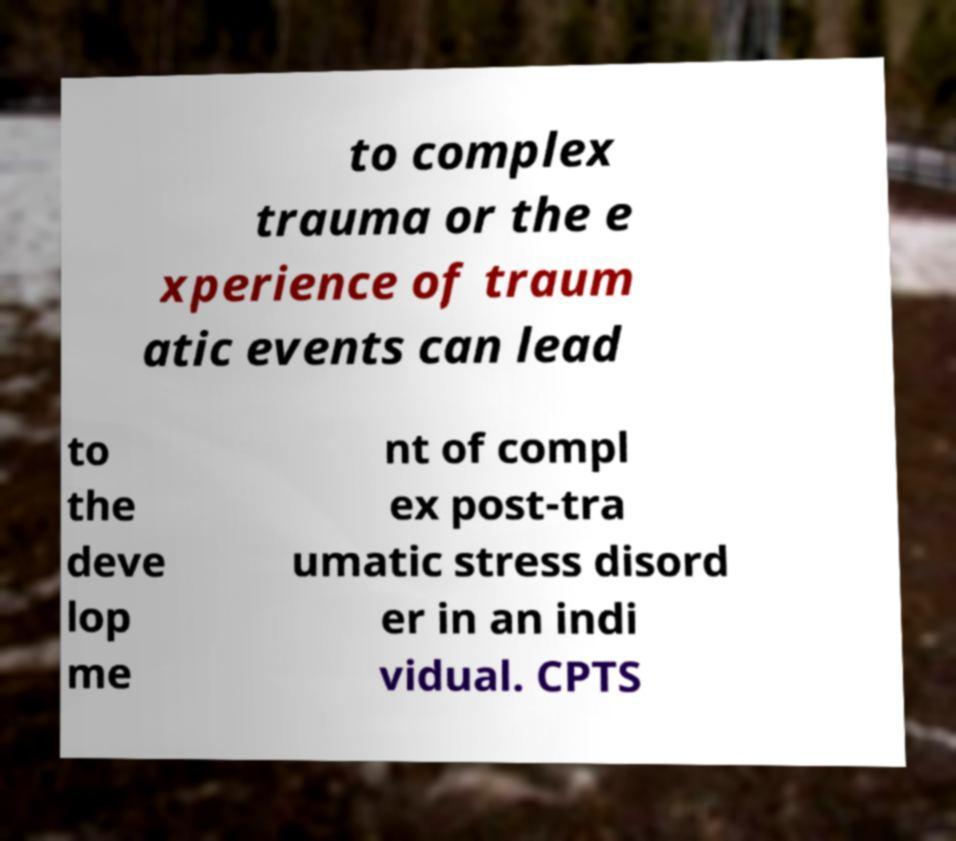For documentation purposes, I need the text within this image transcribed. Could you provide that? to complex trauma or the e xperience of traum atic events can lead to the deve lop me nt of compl ex post-tra umatic stress disord er in an indi vidual. CPTS 